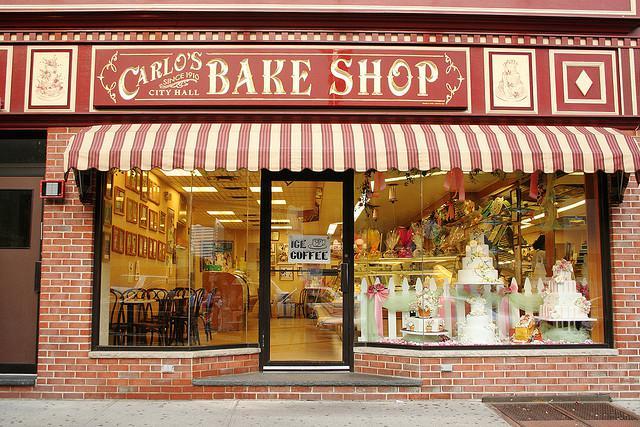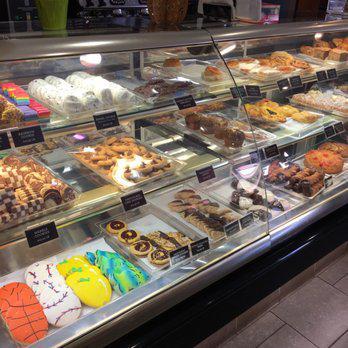The first image is the image on the left, the second image is the image on the right. For the images shown, is this caption "There are windows in the image on the right." true? Answer yes or no. No. 